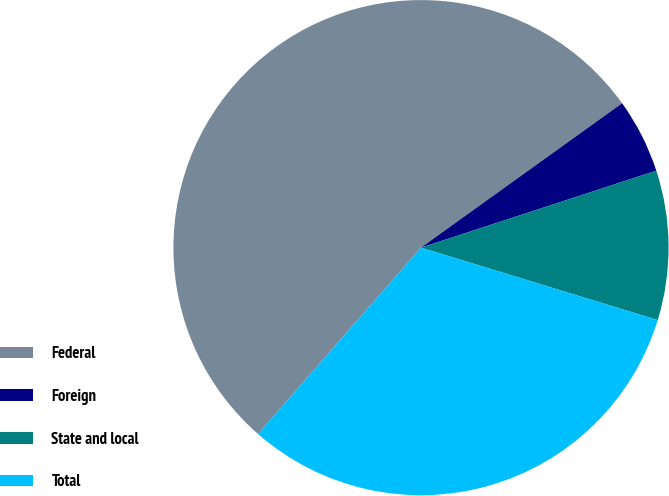<chart> <loc_0><loc_0><loc_500><loc_500><pie_chart><fcel>Federal<fcel>Foreign<fcel>State and local<fcel>Total<nl><fcel>53.66%<fcel>4.88%<fcel>9.76%<fcel>31.71%<nl></chart> 